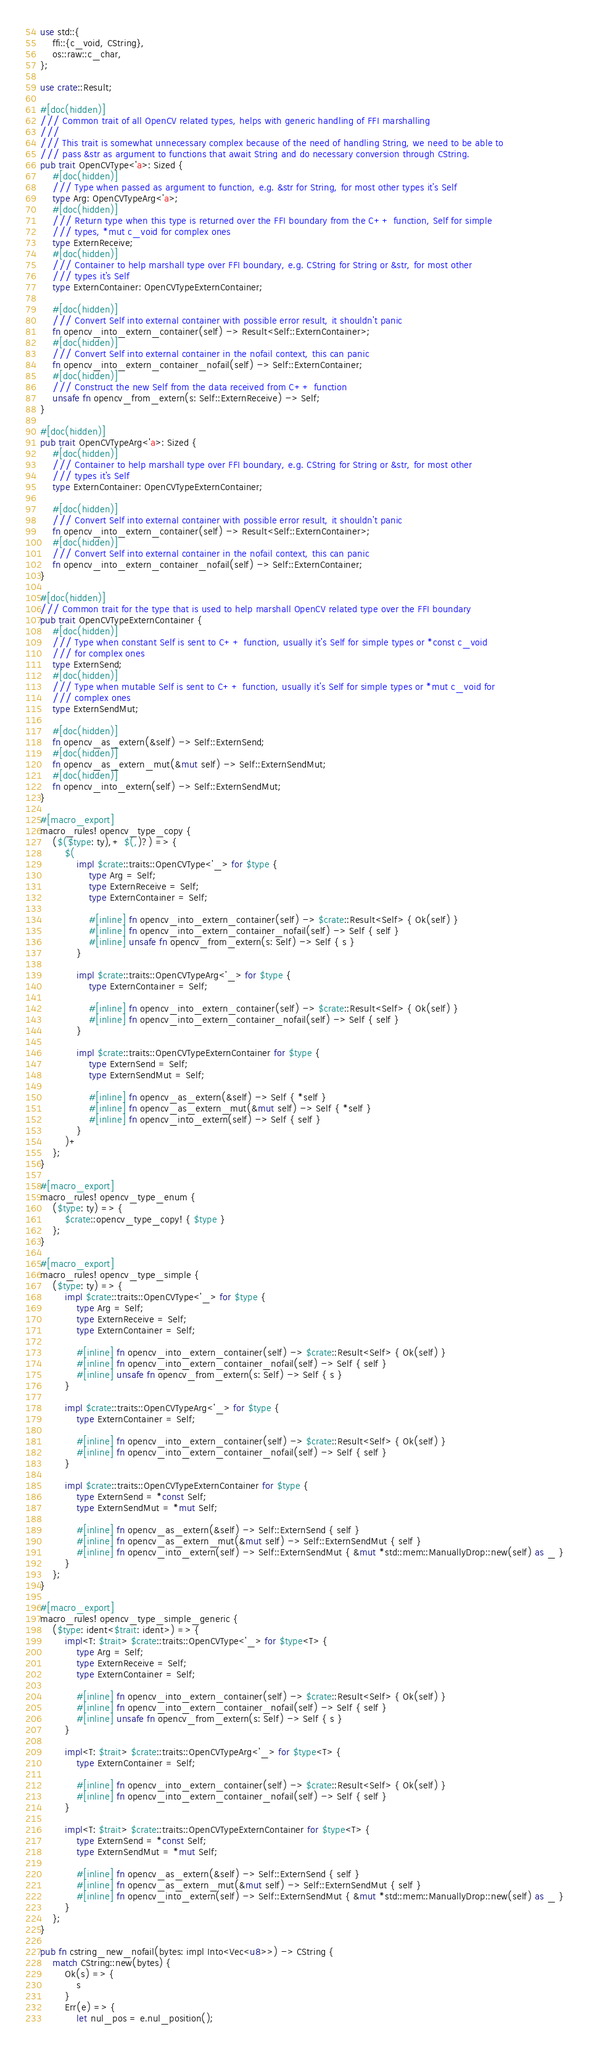Convert code to text. <code><loc_0><loc_0><loc_500><loc_500><_Rust_>use std::{
	ffi::{c_void, CString},
	os::raw::c_char,
};

use crate::Result;

#[doc(hidden)]
/// Common trait of all OpenCV related types, helps with generic handling of FFI marshalling
///
/// This trait is somewhat unnecessary complex because of the need of handling String, we need to be able to
/// pass &str as argument to functions that await String and do necessary conversion through CString.
pub trait OpenCVType<'a>: Sized {
	#[doc(hidden)]
	/// Type when passed as argument to function, e.g. &str for String, for most other types it's Self
	type Arg: OpenCVTypeArg<'a>;
	#[doc(hidden)]
	/// Return type when this type is returned over the FFI boundary from the C++ function, Self for simple
	/// types, *mut c_void for complex ones
	type ExternReceive;
	#[doc(hidden)]
	/// Container to help marshall type over FFI boundary, e.g. CString for String or &str, for most other
	/// types it's Self
	type ExternContainer: OpenCVTypeExternContainer;

	#[doc(hidden)]
	/// Convert Self into external container with possible error result, it shouldn't panic
	fn opencv_into_extern_container(self) -> Result<Self::ExternContainer>;
	#[doc(hidden)]
	/// Convert Self into external container in the nofail context, this can panic
	fn opencv_into_extern_container_nofail(self) -> Self::ExternContainer;
	#[doc(hidden)]
	/// Construct the new Self from the data received from C++ function
	unsafe fn opencv_from_extern(s: Self::ExternReceive) -> Self;
}

#[doc(hidden)]
pub trait OpenCVTypeArg<'a>: Sized {
	#[doc(hidden)]
	/// Container to help marshall type over FFI boundary, e.g. CString for String or &str, for most other
	/// types it's Self
	type ExternContainer: OpenCVTypeExternContainer;

	#[doc(hidden)]
	/// Convert Self into external container with possible error result, it shouldn't panic
	fn opencv_into_extern_container(self) -> Result<Self::ExternContainer>;
	#[doc(hidden)]
	/// Convert Self into external container in the nofail context, this can panic
	fn opencv_into_extern_container_nofail(self) -> Self::ExternContainer;
}

#[doc(hidden)]
/// Common trait for the type that is used to help marshall OpenCV related type over the FFI boundary
pub trait OpenCVTypeExternContainer {
	#[doc(hidden)]
	/// Type when constant Self is sent to C++ function, usually it's Self for simple types or *const c_void
	/// for complex ones
	type ExternSend;
	#[doc(hidden)]
	/// Type when mutable Self is sent to C++ function, usually it's Self for simple types or *mut c_void for
	/// complex ones
	type ExternSendMut;

	#[doc(hidden)]
	fn opencv_as_extern(&self) -> Self::ExternSend;
	#[doc(hidden)]
	fn opencv_as_extern_mut(&mut self) -> Self::ExternSendMut;
	#[doc(hidden)]
	fn opencv_into_extern(self) -> Self::ExternSendMut;
}

#[macro_export]
macro_rules! opencv_type_copy {
	($($type: ty),+ $(,)?) => {
		$(
			impl $crate::traits::OpenCVType<'_> for $type {
				type Arg = Self;
				type ExternReceive = Self;
				type ExternContainer = Self;

				#[inline] fn opencv_into_extern_container(self) -> $crate::Result<Self> { Ok(self) }
				#[inline] fn opencv_into_extern_container_nofail(self) -> Self { self }
				#[inline] unsafe fn opencv_from_extern(s: Self) -> Self { s }
			}

			impl $crate::traits::OpenCVTypeArg<'_> for $type {
				type ExternContainer = Self;

				#[inline] fn opencv_into_extern_container(self) -> $crate::Result<Self> { Ok(self) }
				#[inline] fn opencv_into_extern_container_nofail(self) -> Self { self }
			}

			impl $crate::traits::OpenCVTypeExternContainer for $type {
				type ExternSend = Self;
				type ExternSendMut = Self;

				#[inline] fn opencv_as_extern(&self) -> Self { *self }
				#[inline] fn opencv_as_extern_mut(&mut self) -> Self { *self }
				#[inline] fn opencv_into_extern(self) -> Self { self }
			}
		)+
	};
}

#[macro_export]
macro_rules! opencv_type_enum {
	($type: ty) => {
		$crate::opencv_type_copy! { $type }
	};
}

#[macro_export]
macro_rules! opencv_type_simple {
	($type: ty) => {
		impl $crate::traits::OpenCVType<'_> for $type {
			type Arg = Self;
			type ExternReceive = Self;
			type ExternContainer = Self;

			#[inline] fn opencv_into_extern_container(self) -> $crate::Result<Self> { Ok(self) }
			#[inline] fn opencv_into_extern_container_nofail(self) -> Self { self }
			#[inline] unsafe fn opencv_from_extern(s: Self) -> Self { s }
		}

		impl $crate::traits::OpenCVTypeArg<'_> for $type {
			type ExternContainer = Self;

			#[inline] fn opencv_into_extern_container(self) -> $crate::Result<Self> { Ok(self) }
			#[inline] fn opencv_into_extern_container_nofail(self) -> Self { self }
		}

		impl $crate::traits::OpenCVTypeExternContainer for $type {
			type ExternSend = *const Self;
			type ExternSendMut = *mut Self;

			#[inline] fn opencv_as_extern(&self) -> Self::ExternSend { self }
			#[inline] fn opencv_as_extern_mut(&mut self) -> Self::ExternSendMut { self }
			#[inline] fn opencv_into_extern(self) -> Self::ExternSendMut { &mut *std::mem::ManuallyDrop::new(self) as _ }
		}
	};
}

#[macro_export]
macro_rules! opencv_type_simple_generic {
	($type: ident<$trait: ident>) => {
		impl<T: $trait> $crate::traits::OpenCVType<'_> for $type<T> {
			type Arg = Self;
			type ExternReceive = Self;
			type ExternContainer = Self;

			#[inline] fn opencv_into_extern_container(self) -> $crate::Result<Self> { Ok(self) }
			#[inline] fn opencv_into_extern_container_nofail(self) -> Self { self }
			#[inline] unsafe fn opencv_from_extern(s: Self) -> Self { s }
		}

		impl<T: $trait> $crate::traits::OpenCVTypeArg<'_> for $type<T> {
			type ExternContainer = Self;

			#[inline] fn opencv_into_extern_container(self) -> $crate::Result<Self> { Ok(self) }
			#[inline] fn opencv_into_extern_container_nofail(self) -> Self { self }
		}

		impl<T: $trait> $crate::traits::OpenCVTypeExternContainer for $type<T> {
			type ExternSend = *const Self;
			type ExternSendMut = *mut Self;

			#[inline] fn opencv_as_extern(&self) -> Self::ExternSend { self }
			#[inline] fn opencv_as_extern_mut(&mut self) -> Self::ExternSendMut { self }
			#[inline] fn opencv_into_extern(self) -> Self::ExternSendMut { &mut *std::mem::ManuallyDrop::new(self) as _ }
		}
	};
}

pub fn cstring_new_nofail(bytes: impl Into<Vec<u8>>) -> CString {
	match CString::new(bytes) {
		Ok(s) => {
			s
		}
		Err(e) => {
			let nul_pos = e.nul_position();</code> 